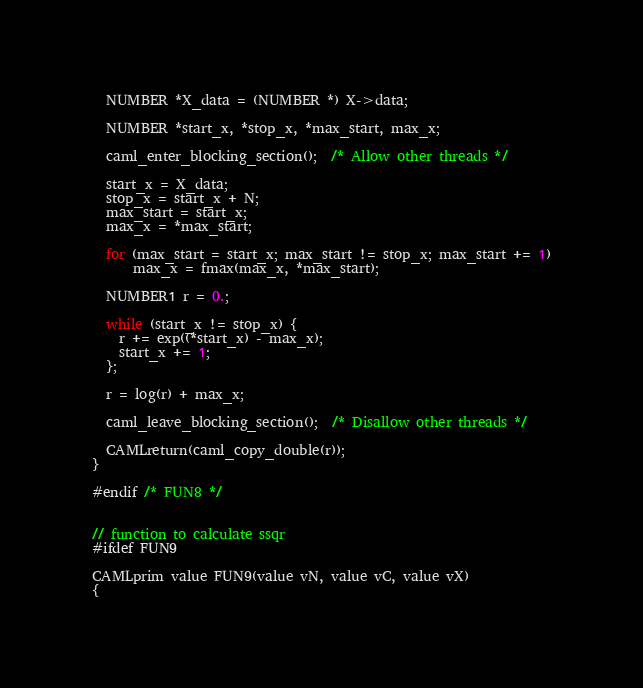Convert code to text. <code><loc_0><loc_0><loc_500><loc_500><_C_>  NUMBER *X_data = (NUMBER *) X->data;

  NUMBER *start_x, *stop_x, *max_start, max_x;

  caml_enter_blocking_section();  /* Allow other threads */

  start_x = X_data;
  stop_x = start_x + N;
  max_start = start_x;
  max_x = *max_start;

  for (max_start = start_x; max_start != stop_x; max_start += 1)
      max_x = fmax(max_x, *max_start);

  NUMBER1 r = 0.;

  while (start_x != stop_x) {
    r += exp((*start_x) - max_x);
    start_x += 1;
  };

  r = log(r) + max_x;

  caml_leave_blocking_section();  /* Disallow other threads */

  CAMLreturn(caml_copy_double(r));
}

#endif /* FUN8 */


// function to calculate ssqr
#ifdef FUN9

CAMLprim value FUN9(value vN, value vC, value vX)
{</code> 